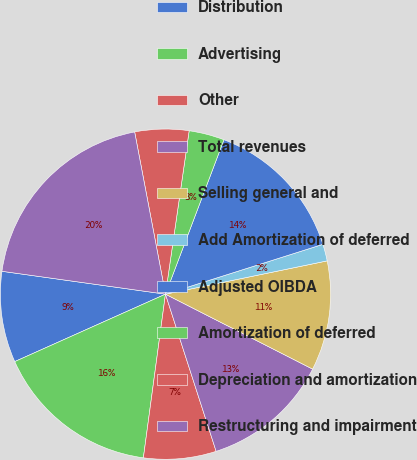Convert chart to OTSL. <chart><loc_0><loc_0><loc_500><loc_500><pie_chart><fcel>Distribution<fcel>Advertising<fcel>Other<fcel>Total revenues<fcel>Selling general and<fcel>Add Amortization of deferred<fcel>Adjusted OIBDA<fcel>Amortization of deferred<fcel>Depreciation and amortization<fcel>Restructuring and impairment<nl><fcel>8.91%<fcel>16.17%<fcel>7.1%<fcel>12.54%<fcel>10.73%<fcel>1.65%<fcel>14.36%<fcel>3.47%<fcel>5.28%<fcel>19.8%<nl></chart> 